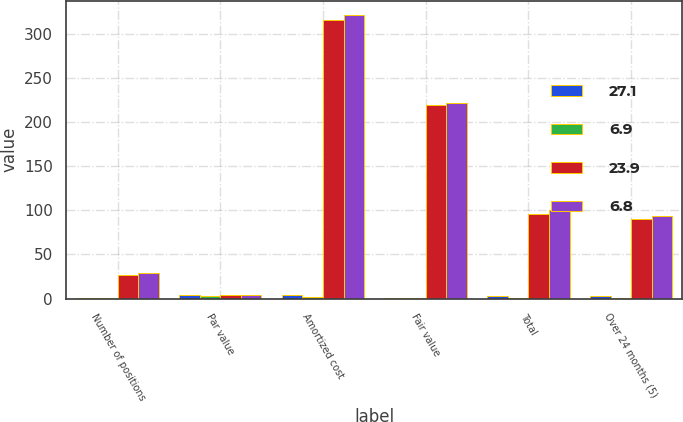Convert chart. <chart><loc_0><loc_0><loc_500><loc_500><stacked_bar_chart><ecel><fcel>Number of positions<fcel>Par value<fcel>Amortized cost<fcel>Fair value<fcel>Total<fcel>Over 24 months (5)<nl><fcel>27.1<fcel>1<fcel>4<fcel>4<fcel>1<fcel>3<fcel>3<nl><fcel>6.9<fcel>1<fcel>3<fcel>2<fcel>1<fcel>1<fcel>1<nl><fcel>23.9<fcel>27<fcel>4<fcel>316<fcel>220<fcel>96<fcel>90<nl><fcel>6.8<fcel>29<fcel>4<fcel>322<fcel>222<fcel>100<fcel>94<nl></chart> 